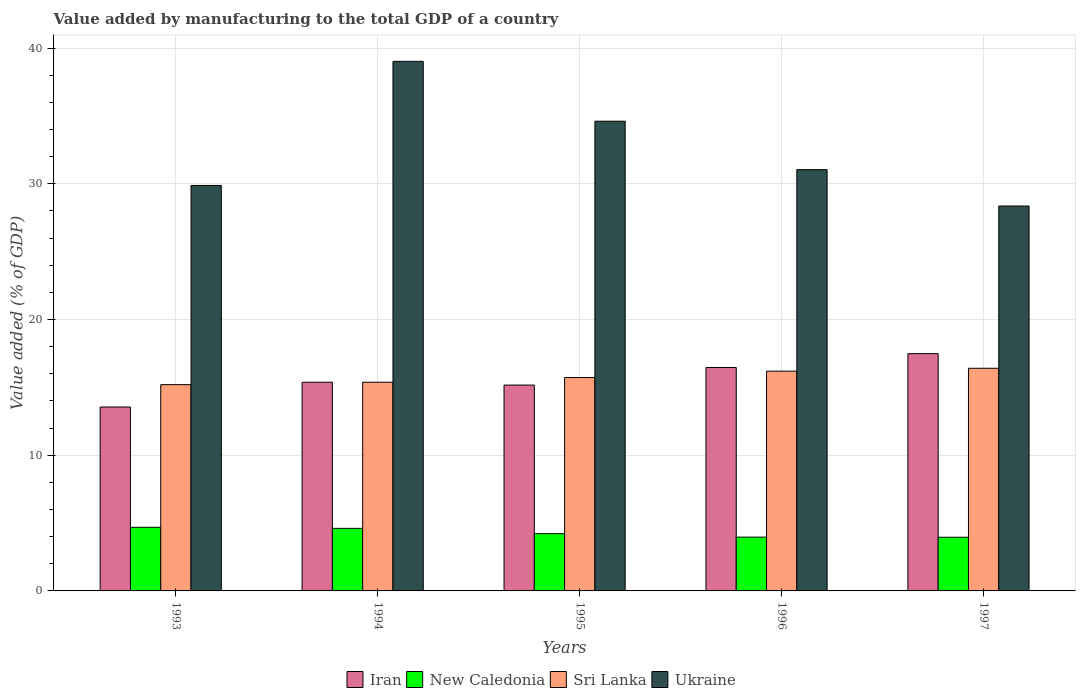How many bars are there on the 5th tick from the left?
Provide a succinct answer. 4. How many bars are there on the 1st tick from the right?
Offer a very short reply. 4. In how many cases, is the number of bars for a given year not equal to the number of legend labels?
Offer a terse response. 0. What is the value added by manufacturing to the total GDP in Sri Lanka in 1994?
Provide a short and direct response. 15.38. Across all years, what is the maximum value added by manufacturing to the total GDP in Iran?
Make the answer very short. 17.49. Across all years, what is the minimum value added by manufacturing to the total GDP in Ukraine?
Your answer should be compact. 28.37. In which year was the value added by manufacturing to the total GDP in Sri Lanka maximum?
Give a very brief answer. 1997. In which year was the value added by manufacturing to the total GDP in Ukraine minimum?
Make the answer very short. 1997. What is the total value added by manufacturing to the total GDP in Ukraine in the graph?
Offer a very short reply. 162.94. What is the difference between the value added by manufacturing to the total GDP in Iran in 1994 and that in 1997?
Provide a succinct answer. -2.11. What is the difference between the value added by manufacturing to the total GDP in Ukraine in 1997 and the value added by manufacturing to the total GDP in New Caledonia in 1996?
Ensure brevity in your answer.  24.4. What is the average value added by manufacturing to the total GDP in Ukraine per year?
Offer a very short reply. 32.59. In the year 1994, what is the difference between the value added by manufacturing to the total GDP in Sri Lanka and value added by manufacturing to the total GDP in New Caledonia?
Make the answer very short. 10.77. What is the ratio of the value added by manufacturing to the total GDP in Ukraine in 1993 to that in 1997?
Keep it short and to the point. 1.05. Is the value added by manufacturing to the total GDP in Ukraine in 1994 less than that in 1995?
Keep it short and to the point. No. Is the difference between the value added by manufacturing to the total GDP in Sri Lanka in 1993 and 1996 greater than the difference between the value added by manufacturing to the total GDP in New Caledonia in 1993 and 1996?
Your answer should be very brief. No. What is the difference between the highest and the second highest value added by manufacturing to the total GDP in Sri Lanka?
Offer a terse response. 0.21. What is the difference between the highest and the lowest value added by manufacturing to the total GDP in Ukraine?
Offer a terse response. 10.66. Is the sum of the value added by manufacturing to the total GDP in Sri Lanka in 1995 and 1997 greater than the maximum value added by manufacturing to the total GDP in Ukraine across all years?
Provide a short and direct response. No. Is it the case that in every year, the sum of the value added by manufacturing to the total GDP in Iran and value added by manufacturing to the total GDP in Ukraine is greater than the sum of value added by manufacturing to the total GDP in Sri Lanka and value added by manufacturing to the total GDP in New Caledonia?
Keep it short and to the point. Yes. What does the 2nd bar from the left in 1996 represents?
Your answer should be very brief. New Caledonia. What does the 1st bar from the right in 1994 represents?
Give a very brief answer. Ukraine. Is it the case that in every year, the sum of the value added by manufacturing to the total GDP in Sri Lanka and value added by manufacturing to the total GDP in Iran is greater than the value added by manufacturing to the total GDP in Ukraine?
Your answer should be very brief. No. How many bars are there?
Your answer should be very brief. 20. How many years are there in the graph?
Provide a short and direct response. 5. Are the values on the major ticks of Y-axis written in scientific E-notation?
Your answer should be very brief. No. How many legend labels are there?
Your response must be concise. 4. How are the legend labels stacked?
Give a very brief answer. Horizontal. What is the title of the graph?
Provide a short and direct response. Value added by manufacturing to the total GDP of a country. Does "United Kingdom" appear as one of the legend labels in the graph?
Keep it short and to the point. No. What is the label or title of the Y-axis?
Offer a terse response. Value added (% of GDP). What is the Value added (% of GDP) in Iran in 1993?
Your response must be concise. 13.55. What is the Value added (% of GDP) of New Caledonia in 1993?
Your answer should be very brief. 4.69. What is the Value added (% of GDP) in Sri Lanka in 1993?
Your answer should be compact. 15.2. What is the Value added (% of GDP) in Ukraine in 1993?
Your response must be concise. 29.88. What is the Value added (% of GDP) of Iran in 1994?
Your answer should be very brief. 15.38. What is the Value added (% of GDP) in New Caledonia in 1994?
Your answer should be very brief. 4.61. What is the Value added (% of GDP) in Sri Lanka in 1994?
Give a very brief answer. 15.38. What is the Value added (% of GDP) in Ukraine in 1994?
Your response must be concise. 39.03. What is the Value added (% of GDP) of Iran in 1995?
Give a very brief answer. 15.17. What is the Value added (% of GDP) of New Caledonia in 1995?
Your answer should be compact. 4.22. What is the Value added (% of GDP) of Sri Lanka in 1995?
Offer a very short reply. 15.73. What is the Value added (% of GDP) in Ukraine in 1995?
Offer a very short reply. 34.62. What is the Value added (% of GDP) in Iran in 1996?
Give a very brief answer. 16.47. What is the Value added (% of GDP) in New Caledonia in 1996?
Offer a terse response. 3.96. What is the Value added (% of GDP) of Sri Lanka in 1996?
Provide a succinct answer. 16.2. What is the Value added (% of GDP) in Ukraine in 1996?
Give a very brief answer. 31.05. What is the Value added (% of GDP) of Iran in 1997?
Keep it short and to the point. 17.49. What is the Value added (% of GDP) in New Caledonia in 1997?
Make the answer very short. 3.96. What is the Value added (% of GDP) in Sri Lanka in 1997?
Your response must be concise. 16.41. What is the Value added (% of GDP) in Ukraine in 1997?
Give a very brief answer. 28.37. Across all years, what is the maximum Value added (% of GDP) of Iran?
Your response must be concise. 17.49. Across all years, what is the maximum Value added (% of GDP) in New Caledonia?
Offer a very short reply. 4.69. Across all years, what is the maximum Value added (% of GDP) in Sri Lanka?
Provide a succinct answer. 16.41. Across all years, what is the maximum Value added (% of GDP) in Ukraine?
Provide a short and direct response. 39.03. Across all years, what is the minimum Value added (% of GDP) in Iran?
Keep it short and to the point. 13.55. Across all years, what is the minimum Value added (% of GDP) in New Caledonia?
Your response must be concise. 3.96. Across all years, what is the minimum Value added (% of GDP) in Sri Lanka?
Offer a very short reply. 15.2. Across all years, what is the minimum Value added (% of GDP) in Ukraine?
Offer a very short reply. 28.37. What is the total Value added (% of GDP) of Iran in the graph?
Provide a short and direct response. 78.06. What is the total Value added (% of GDP) in New Caledonia in the graph?
Ensure brevity in your answer.  21.44. What is the total Value added (% of GDP) of Sri Lanka in the graph?
Provide a short and direct response. 78.91. What is the total Value added (% of GDP) of Ukraine in the graph?
Provide a succinct answer. 162.94. What is the difference between the Value added (% of GDP) in Iran in 1993 and that in 1994?
Your answer should be compact. -1.83. What is the difference between the Value added (% of GDP) of New Caledonia in 1993 and that in 1994?
Your answer should be very brief. 0.08. What is the difference between the Value added (% of GDP) of Sri Lanka in 1993 and that in 1994?
Your response must be concise. -0.18. What is the difference between the Value added (% of GDP) in Ukraine in 1993 and that in 1994?
Offer a terse response. -9.15. What is the difference between the Value added (% of GDP) of Iran in 1993 and that in 1995?
Provide a short and direct response. -1.62. What is the difference between the Value added (% of GDP) of New Caledonia in 1993 and that in 1995?
Make the answer very short. 0.47. What is the difference between the Value added (% of GDP) of Sri Lanka in 1993 and that in 1995?
Provide a succinct answer. -0.52. What is the difference between the Value added (% of GDP) of Ukraine in 1993 and that in 1995?
Make the answer very short. -4.74. What is the difference between the Value added (% of GDP) in Iran in 1993 and that in 1996?
Provide a succinct answer. -2.91. What is the difference between the Value added (% of GDP) of New Caledonia in 1993 and that in 1996?
Give a very brief answer. 0.72. What is the difference between the Value added (% of GDP) in Sri Lanka in 1993 and that in 1996?
Your answer should be very brief. -1. What is the difference between the Value added (% of GDP) of Ukraine in 1993 and that in 1996?
Offer a terse response. -1.17. What is the difference between the Value added (% of GDP) in Iran in 1993 and that in 1997?
Keep it short and to the point. -3.93. What is the difference between the Value added (% of GDP) in New Caledonia in 1993 and that in 1997?
Your answer should be compact. 0.73. What is the difference between the Value added (% of GDP) in Sri Lanka in 1993 and that in 1997?
Keep it short and to the point. -1.21. What is the difference between the Value added (% of GDP) of Ukraine in 1993 and that in 1997?
Your answer should be very brief. 1.52. What is the difference between the Value added (% of GDP) in Iran in 1994 and that in 1995?
Offer a terse response. 0.21. What is the difference between the Value added (% of GDP) of New Caledonia in 1994 and that in 1995?
Your response must be concise. 0.39. What is the difference between the Value added (% of GDP) of Sri Lanka in 1994 and that in 1995?
Offer a very short reply. -0.35. What is the difference between the Value added (% of GDP) of Ukraine in 1994 and that in 1995?
Provide a short and direct response. 4.41. What is the difference between the Value added (% of GDP) in Iran in 1994 and that in 1996?
Your answer should be very brief. -1.09. What is the difference between the Value added (% of GDP) of New Caledonia in 1994 and that in 1996?
Offer a very short reply. 0.65. What is the difference between the Value added (% of GDP) of Sri Lanka in 1994 and that in 1996?
Your response must be concise. -0.82. What is the difference between the Value added (% of GDP) in Ukraine in 1994 and that in 1996?
Offer a very short reply. 7.98. What is the difference between the Value added (% of GDP) in Iran in 1994 and that in 1997?
Offer a very short reply. -2.11. What is the difference between the Value added (% of GDP) in New Caledonia in 1994 and that in 1997?
Offer a terse response. 0.65. What is the difference between the Value added (% of GDP) of Sri Lanka in 1994 and that in 1997?
Your answer should be compact. -1.03. What is the difference between the Value added (% of GDP) of Ukraine in 1994 and that in 1997?
Give a very brief answer. 10.66. What is the difference between the Value added (% of GDP) in Iran in 1995 and that in 1996?
Provide a succinct answer. -1.3. What is the difference between the Value added (% of GDP) of New Caledonia in 1995 and that in 1996?
Give a very brief answer. 0.25. What is the difference between the Value added (% of GDP) in Sri Lanka in 1995 and that in 1996?
Ensure brevity in your answer.  -0.47. What is the difference between the Value added (% of GDP) in Ukraine in 1995 and that in 1996?
Your answer should be compact. 3.57. What is the difference between the Value added (% of GDP) of Iran in 1995 and that in 1997?
Provide a succinct answer. -2.32. What is the difference between the Value added (% of GDP) of New Caledonia in 1995 and that in 1997?
Your response must be concise. 0.26. What is the difference between the Value added (% of GDP) in Sri Lanka in 1995 and that in 1997?
Your answer should be compact. -0.68. What is the difference between the Value added (% of GDP) of Ukraine in 1995 and that in 1997?
Offer a terse response. 6.25. What is the difference between the Value added (% of GDP) in Iran in 1996 and that in 1997?
Your answer should be very brief. -1.02. What is the difference between the Value added (% of GDP) of New Caledonia in 1996 and that in 1997?
Provide a short and direct response. 0.01. What is the difference between the Value added (% of GDP) in Sri Lanka in 1996 and that in 1997?
Ensure brevity in your answer.  -0.21. What is the difference between the Value added (% of GDP) in Ukraine in 1996 and that in 1997?
Make the answer very short. 2.68. What is the difference between the Value added (% of GDP) in Iran in 1993 and the Value added (% of GDP) in New Caledonia in 1994?
Provide a short and direct response. 8.94. What is the difference between the Value added (% of GDP) in Iran in 1993 and the Value added (% of GDP) in Sri Lanka in 1994?
Make the answer very short. -1.83. What is the difference between the Value added (% of GDP) of Iran in 1993 and the Value added (% of GDP) of Ukraine in 1994?
Provide a succinct answer. -25.47. What is the difference between the Value added (% of GDP) in New Caledonia in 1993 and the Value added (% of GDP) in Sri Lanka in 1994?
Your response must be concise. -10.69. What is the difference between the Value added (% of GDP) in New Caledonia in 1993 and the Value added (% of GDP) in Ukraine in 1994?
Provide a short and direct response. -34.34. What is the difference between the Value added (% of GDP) in Sri Lanka in 1993 and the Value added (% of GDP) in Ukraine in 1994?
Give a very brief answer. -23.83. What is the difference between the Value added (% of GDP) of Iran in 1993 and the Value added (% of GDP) of New Caledonia in 1995?
Provide a succinct answer. 9.34. What is the difference between the Value added (% of GDP) in Iran in 1993 and the Value added (% of GDP) in Sri Lanka in 1995?
Your answer should be compact. -2.17. What is the difference between the Value added (% of GDP) of Iran in 1993 and the Value added (% of GDP) of Ukraine in 1995?
Give a very brief answer. -21.06. What is the difference between the Value added (% of GDP) in New Caledonia in 1993 and the Value added (% of GDP) in Sri Lanka in 1995?
Keep it short and to the point. -11.04. What is the difference between the Value added (% of GDP) of New Caledonia in 1993 and the Value added (% of GDP) of Ukraine in 1995?
Ensure brevity in your answer.  -29.93. What is the difference between the Value added (% of GDP) of Sri Lanka in 1993 and the Value added (% of GDP) of Ukraine in 1995?
Your response must be concise. -19.41. What is the difference between the Value added (% of GDP) of Iran in 1993 and the Value added (% of GDP) of New Caledonia in 1996?
Keep it short and to the point. 9.59. What is the difference between the Value added (% of GDP) of Iran in 1993 and the Value added (% of GDP) of Sri Lanka in 1996?
Provide a short and direct response. -2.64. What is the difference between the Value added (% of GDP) in Iran in 1993 and the Value added (% of GDP) in Ukraine in 1996?
Offer a terse response. -17.49. What is the difference between the Value added (% of GDP) in New Caledonia in 1993 and the Value added (% of GDP) in Sri Lanka in 1996?
Keep it short and to the point. -11.51. What is the difference between the Value added (% of GDP) of New Caledonia in 1993 and the Value added (% of GDP) of Ukraine in 1996?
Your answer should be compact. -26.36. What is the difference between the Value added (% of GDP) of Sri Lanka in 1993 and the Value added (% of GDP) of Ukraine in 1996?
Provide a short and direct response. -15.84. What is the difference between the Value added (% of GDP) of Iran in 1993 and the Value added (% of GDP) of New Caledonia in 1997?
Offer a terse response. 9.6. What is the difference between the Value added (% of GDP) in Iran in 1993 and the Value added (% of GDP) in Sri Lanka in 1997?
Ensure brevity in your answer.  -2.85. What is the difference between the Value added (% of GDP) in Iran in 1993 and the Value added (% of GDP) in Ukraine in 1997?
Give a very brief answer. -14.81. What is the difference between the Value added (% of GDP) in New Caledonia in 1993 and the Value added (% of GDP) in Sri Lanka in 1997?
Give a very brief answer. -11.72. What is the difference between the Value added (% of GDP) of New Caledonia in 1993 and the Value added (% of GDP) of Ukraine in 1997?
Make the answer very short. -23.68. What is the difference between the Value added (% of GDP) of Sri Lanka in 1993 and the Value added (% of GDP) of Ukraine in 1997?
Provide a short and direct response. -13.16. What is the difference between the Value added (% of GDP) in Iran in 1994 and the Value added (% of GDP) in New Caledonia in 1995?
Give a very brief answer. 11.16. What is the difference between the Value added (% of GDP) in Iran in 1994 and the Value added (% of GDP) in Sri Lanka in 1995?
Give a very brief answer. -0.35. What is the difference between the Value added (% of GDP) in Iran in 1994 and the Value added (% of GDP) in Ukraine in 1995?
Make the answer very short. -19.24. What is the difference between the Value added (% of GDP) of New Caledonia in 1994 and the Value added (% of GDP) of Sri Lanka in 1995?
Ensure brevity in your answer.  -11.12. What is the difference between the Value added (% of GDP) in New Caledonia in 1994 and the Value added (% of GDP) in Ukraine in 1995?
Make the answer very short. -30.01. What is the difference between the Value added (% of GDP) of Sri Lanka in 1994 and the Value added (% of GDP) of Ukraine in 1995?
Provide a succinct answer. -19.24. What is the difference between the Value added (% of GDP) in Iran in 1994 and the Value added (% of GDP) in New Caledonia in 1996?
Provide a succinct answer. 11.42. What is the difference between the Value added (% of GDP) of Iran in 1994 and the Value added (% of GDP) of Sri Lanka in 1996?
Offer a very short reply. -0.82. What is the difference between the Value added (% of GDP) of Iran in 1994 and the Value added (% of GDP) of Ukraine in 1996?
Ensure brevity in your answer.  -15.67. What is the difference between the Value added (% of GDP) of New Caledonia in 1994 and the Value added (% of GDP) of Sri Lanka in 1996?
Provide a succinct answer. -11.59. What is the difference between the Value added (% of GDP) of New Caledonia in 1994 and the Value added (% of GDP) of Ukraine in 1996?
Your answer should be very brief. -26.44. What is the difference between the Value added (% of GDP) of Sri Lanka in 1994 and the Value added (% of GDP) of Ukraine in 1996?
Keep it short and to the point. -15.67. What is the difference between the Value added (% of GDP) in Iran in 1994 and the Value added (% of GDP) in New Caledonia in 1997?
Your answer should be very brief. 11.42. What is the difference between the Value added (% of GDP) of Iran in 1994 and the Value added (% of GDP) of Sri Lanka in 1997?
Give a very brief answer. -1.03. What is the difference between the Value added (% of GDP) of Iran in 1994 and the Value added (% of GDP) of Ukraine in 1997?
Provide a short and direct response. -12.99. What is the difference between the Value added (% of GDP) in New Caledonia in 1994 and the Value added (% of GDP) in Sri Lanka in 1997?
Offer a terse response. -11.8. What is the difference between the Value added (% of GDP) in New Caledonia in 1994 and the Value added (% of GDP) in Ukraine in 1997?
Keep it short and to the point. -23.76. What is the difference between the Value added (% of GDP) in Sri Lanka in 1994 and the Value added (% of GDP) in Ukraine in 1997?
Offer a very short reply. -12.99. What is the difference between the Value added (% of GDP) in Iran in 1995 and the Value added (% of GDP) in New Caledonia in 1996?
Provide a succinct answer. 11.21. What is the difference between the Value added (% of GDP) in Iran in 1995 and the Value added (% of GDP) in Sri Lanka in 1996?
Provide a succinct answer. -1.03. What is the difference between the Value added (% of GDP) of Iran in 1995 and the Value added (% of GDP) of Ukraine in 1996?
Keep it short and to the point. -15.88. What is the difference between the Value added (% of GDP) in New Caledonia in 1995 and the Value added (% of GDP) in Sri Lanka in 1996?
Keep it short and to the point. -11.98. What is the difference between the Value added (% of GDP) of New Caledonia in 1995 and the Value added (% of GDP) of Ukraine in 1996?
Your answer should be compact. -26.83. What is the difference between the Value added (% of GDP) of Sri Lanka in 1995 and the Value added (% of GDP) of Ukraine in 1996?
Your response must be concise. -15.32. What is the difference between the Value added (% of GDP) in Iran in 1995 and the Value added (% of GDP) in New Caledonia in 1997?
Ensure brevity in your answer.  11.22. What is the difference between the Value added (% of GDP) of Iran in 1995 and the Value added (% of GDP) of Sri Lanka in 1997?
Your answer should be compact. -1.24. What is the difference between the Value added (% of GDP) of Iran in 1995 and the Value added (% of GDP) of Ukraine in 1997?
Provide a succinct answer. -13.19. What is the difference between the Value added (% of GDP) in New Caledonia in 1995 and the Value added (% of GDP) in Sri Lanka in 1997?
Provide a succinct answer. -12.19. What is the difference between the Value added (% of GDP) in New Caledonia in 1995 and the Value added (% of GDP) in Ukraine in 1997?
Provide a short and direct response. -24.15. What is the difference between the Value added (% of GDP) of Sri Lanka in 1995 and the Value added (% of GDP) of Ukraine in 1997?
Make the answer very short. -12.64. What is the difference between the Value added (% of GDP) in Iran in 1996 and the Value added (% of GDP) in New Caledonia in 1997?
Provide a short and direct response. 12.51. What is the difference between the Value added (% of GDP) in Iran in 1996 and the Value added (% of GDP) in Sri Lanka in 1997?
Provide a short and direct response. 0.06. What is the difference between the Value added (% of GDP) in Iran in 1996 and the Value added (% of GDP) in Ukraine in 1997?
Provide a succinct answer. -11.9. What is the difference between the Value added (% of GDP) in New Caledonia in 1996 and the Value added (% of GDP) in Sri Lanka in 1997?
Provide a short and direct response. -12.44. What is the difference between the Value added (% of GDP) in New Caledonia in 1996 and the Value added (% of GDP) in Ukraine in 1997?
Keep it short and to the point. -24.4. What is the difference between the Value added (% of GDP) of Sri Lanka in 1996 and the Value added (% of GDP) of Ukraine in 1997?
Make the answer very short. -12.17. What is the average Value added (% of GDP) in Iran per year?
Your response must be concise. 15.61. What is the average Value added (% of GDP) in New Caledonia per year?
Provide a short and direct response. 4.29. What is the average Value added (% of GDP) of Sri Lanka per year?
Offer a very short reply. 15.78. What is the average Value added (% of GDP) of Ukraine per year?
Keep it short and to the point. 32.59. In the year 1993, what is the difference between the Value added (% of GDP) of Iran and Value added (% of GDP) of New Caledonia?
Make the answer very short. 8.87. In the year 1993, what is the difference between the Value added (% of GDP) of Iran and Value added (% of GDP) of Sri Lanka?
Offer a very short reply. -1.65. In the year 1993, what is the difference between the Value added (% of GDP) in Iran and Value added (% of GDP) in Ukraine?
Keep it short and to the point. -16.33. In the year 1993, what is the difference between the Value added (% of GDP) in New Caledonia and Value added (% of GDP) in Sri Lanka?
Provide a short and direct response. -10.51. In the year 1993, what is the difference between the Value added (% of GDP) in New Caledonia and Value added (% of GDP) in Ukraine?
Provide a succinct answer. -25.19. In the year 1993, what is the difference between the Value added (% of GDP) in Sri Lanka and Value added (% of GDP) in Ukraine?
Provide a short and direct response. -14.68. In the year 1994, what is the difference between the Value added (% of GDP) of Iran and Value added (% of GDP) of New Caledonia?
Your answer should be compact. 10.77. In the year 1994, what is the difference between the Value added (% of GDP) of Iran and Value added (% of GDP) of Ukraine?
Make the answer very short. -23.65. In the year 1994, what is the difference between the Value added (% of GDP) in New Caledonia and Value added (% of GDP) in Sri Lanka?
Make the answer very short. -10.77. In the year 1994, what is the difference between the Value added (% of GDP) of New Caledonia and Value added (% of GDP) of Ukraine?
Give a very brief answer. -34.42. In the year 1994, what is the difference between the Value added (% of GDP) in Sri Lanka and Value added (% of GDP) in Ukraine?
Keep it short and to the point. -23.65. In the year 1995, what is the difference between the Value added (% of GDP) in Iran and Value added (% of GDP) in New Caledonia?
Your answer should be compact. 10.95. In the year 1995, what is the difference between the Value added (% of GDP) of Iran and Value added (% of GDP) of Sri Lanka?
Give a very brief answer. -0.56. In the year 1995, what is the difference between the Value added (% of GDP) of Iran and Value added (% of GDP) of Ukraine?
Provide a short and direct response. -19.45. In the year 1995, what is the difference between the Value added (% of GDP) in New Caledonia and Value added (% of GDP) in Sri Lanka?
Provide a succinct answer. -11.51. In the year 1995, what is the difference between the Value added (% of GDP) in New Caledonia and Value added (% of GDP) in Ukraine?
Give a very brief answer. -30.4. In the year 1995, what is the difference between the Value added (% of GDP) in Sri Lanka and Value added (% of GDP) in Ukraine?
Your response must be concise. -18.89. In the year 1996, what is the difference between the Value added (% of GDP) of Iran and Value added (% of GDP) of New Caledonia?
Your answer should be very brief. 12.5. In the year 1996, what is the difference between the Value added (% of GDP) of Iran and Value added (% of GDP) of Sri Lanka?
Provide a short and direct response. 0.27. In the year 1996, what is the difference between the Value added (% of GDP) of Iran and Value added (% of GDP) of Ukraine?
Give a very brief answer. -14.58. In the year 1996, what is the difference between the Value added (% of GDP) of New Caledonia and Value added (% of GDP) of Sri Lanka?
Your answer should be compact. -12.23. In the year 1996, what is the difference between the Value added (% of GDP) in New Caledonia and Value added (% of GDP) in Ukraine?
Ensure brevity in your answer.  -27.08. In the year 1996, what is the difference between the Value added (% of GDP) in Sri Lanka and Value added (% of GDP) in Ukraine?
Make the answer very short. -14.85. In the year 1997, what is the difference between the Value added (% of GDP) in Iran and Value added (% of GDP) in New Caledonia?
Offer a terse response. 13.53. In the year 1997, what is the difference between the Value added (% of GDP) in Iran and Value added (% of GDP) in Sri Lanka?
Provide a short and direct response. 1.08. In the year 1997, what is the difference between the Value added (% of GDP) of Iran and Value added (% of GDP) of Ukraine?
Provide a short and direct response. -10.88. In the year 1997, what is the difference between the Value added (% of GDP) in New Caledonia and Value added (% of GDP) in Sri Lanka?
Provide a succinct answer. -12.45. In the year 1997, what is the difference between the Value added (% of GDP) of New Caledonia and Value added (% of GDP) of Ukraine?
Your response must be concise. -24.41. In the year 1997, what is the difference between the Value added (% of GDP) in Sri Lanka and Value added (% of GDP) in Ukraine?
Offer a terse response. -11.96. What is the ratio of the Value added (% of GDP) in Iran in 1993 to that in 1994?
Keep it short and to the point. 0.88. What is the ratio of the Value added (% of GDP) of New Caledonia in 1993 to that in 1994?
Make the answer very short. 1.02. What is the ratio of the Value added (% of GDP) in Ukraine in 1993 to that in 1994?
Give a very brief answer. 0.77. What is the ratio of the Value added (% of GDP) in Iran in 1993 to that in 1995?
Give a very brief answer. 0.89. What is the ratio of the Value added (% of GDP) of New Caledonia in 1993 to that in 1995?
Offer a very short reply. 1.11. What is the ratio of the Value added (% of GDP) of Sri Lanka in 1993 to that in 1995?
Make the answer very short. 0.97. What is the ratio of the Value added (% of GDP) in Ukraine in 1993 to that in 1995?
Offer a terse response. 0.86. What is the ratio of the Value added (% of GDP) of Iran in 1993 to that in 1996?
Offer a terse response. 0.82. What is the ratio of the Value added (% of GDP) of New Caledonia in 1993 to that in 1996?
Keep it short and to the point. 1.18. What is the ratio of the Value added (% of GDP) of Sri Lanka in 1993 to that in 1996?
Offer a terse response. 0.94. What is the ratio of the Value added (% of GDP) in Ukraine in 1993 to that in 1996?
Offer a terse response. 0.96. What is the ratio of the Value added (% of GDP) of Iran in 1993 to that in 1997?
Offer a very short reply. 0.78. What is the ratio of the Value added (% of GDP) in New Caledonia in 1993 to that in 1997?
Offer a terse response. 1.19. What is the ratio of the Value added (% of GDP) of Sri Lanka in 1993 to that in 1997?
Provide a succinct answer. 0.93. What is the ratio of the Value added (% of GDP) in Ukraine in 1993 to that in 1997?
Give a very brief answer. 1.05. What is the ratio of the Value added (% of GDP) in Iran in 1994 to that in 1995?
Provide a succinct answer. 1.01. What is the ratio of the Value added (% of GDP) of New Caledonia in 1994 to that in 1995?
Provide a succinct answer. 1.09. What is the ratio of the Value added (% of GDP) of Sri Lanka in 1994 to that in 1995?
Provide a short and direct response. 0.98. What is the ratio of the Value added (% of GDP) in Ukraine in 1994 to that in 1995?
Give a very brief answer. 1.13. What is the ratio of the Value added (% of GDP) in Iran in 1994 to that in 1996?
Provide a short and direct response. 0.93. What is the ratio of the Value added (% of GDP) of New Caledonia in 1994 to that in 1996?
Your response must be concise. 1.16. What is the ratio of the Value added (% of GDP) of Sri Lanka in 1994 to that in 1996?
Give a very brief answer. 0.95. What is the ratio of the Value added (% of GDP) of Ukraine in 1994 to that in 1996?
Your response must be concise. 1.26. What is the ratio of the Value added (% of GDP) in Iran in 1994 to that in 1997?
Make the answer very short. 0.88. What is the ratio of the Value added (% of GDP) in New Caledonia in 1994 to that in 1997?
Give a very brief answer. 1.17. What is the ratio of the Value added (% of GDP) in Sri Lanka in 1994 to that in 1997?
Provide a succinct answer. 0.94. What is the ratio of the Value added (% of GDP) in Ukraine in 1994 to that in 1997?
Give a very brief answer. 1.38. What is the ratio of the Value added (% of GDP) of Iran in 1995 to that in 1996?
Your answer should be very brief. 0.92. What is the ratio of the Value added (% of GDP) of New Caledonia in 1995 to that in 1996?
Your answer should be very brief. 1.06. What is the ratio of the Value added (% of GDP) in Sri Lanka in 1995 to that in 1996?
Your response must be concise. 0.97. What is the ratio of the Value added (% of GDP) of Ukraine in 1995 to that in 1996?
Make the answer very short. 1.11. What is the ratio of the Value added (% of GDP) in Iran in 1995 to that in 1997?
Keep it short and to the point. 0.87. What is the ratio of the Value added (% of GDP) in New Caledonia in 1995 to that in 1997?
Your response must be concise. 1.07. What is the ratio of the Value added (% of GDP) of Sri Lanka in 1995 to that in 1997?
Provide a succinct answer. 0.96. What is the ratio of the Value added (% of GDP) in Ukraine in 1995 to that in 1997?
Offer a terse response. 1.22. What is the ratio of the Value added (% of GDP) in Iran in 1996 to that in 1997?
Provide a short and direct response. 0.94. What is the ratio of the Value added (% of GDP) in New Caledonia in 1996 to that in 1997?
Offer a very short reply. 1. What is the ratio of the Value added (% of GDP) in Sri Lanka in 1996 to that in 1997?
Offer a terse response. 0.99. What is the ratio of the Value added (% of GDP) of Ukraine in 1996 to that in 1997?
Offer a terse response. 1.09. What is the difference between the highest and the second highest Value added (% of GDP) of Iran?
Your response must be concise. 1.02. What is the difference between the highest and the second highest Value added (% of GDP) in New Caledonia?
Your answer should be compact. 0.08. What is the difference between the highest and the second highest Value added (% of GDP) in Sri Lanka?
Keep it short and to the point. 0.21. What is the difference between the highest and the second highest Value added (% of GDP) in Ukraine?
Your response must be concise. 4.41. What is the difference between the highest and the lowest Value added (% of GDP) of Iran?
Your answer should be compact. 3.93. What is the difference between the highest and the lowest Value added (% of GDP) of New Caledonia?
Give a very brief answer. 0.73. What is the difference between the highest and the lowest Value added (% of GDP) in Sri Lanka?
Offer a terse response. 1.21. What is the difference between the highest and the lowest Value added (% of GDP) of Ukraine?
Provide a succinct answer. 10.66. 